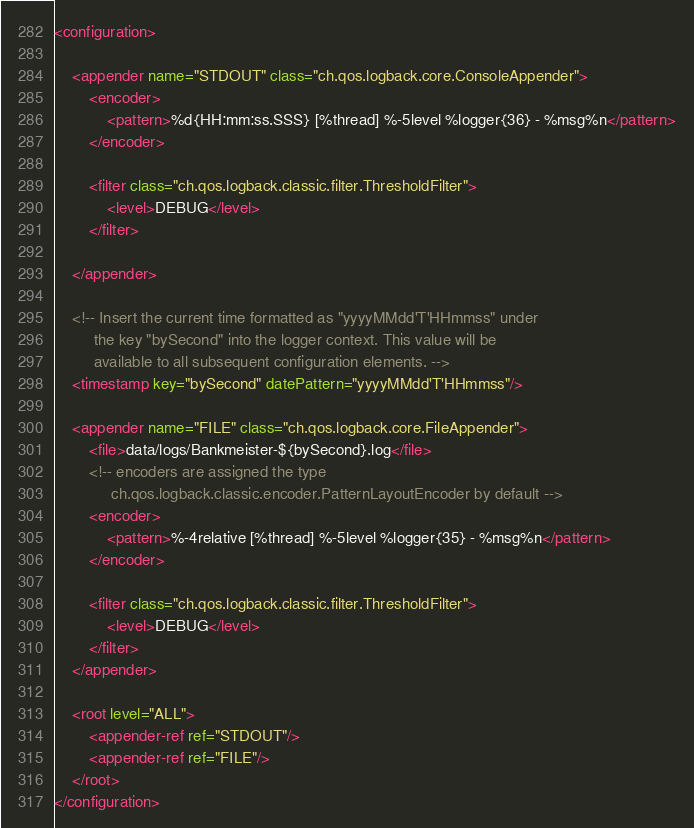Convert code to text. <code><loc_0><loc_0><loc_500><loc_500><_XML_><configuration>

    <appender name="STDOUT" class="ch.qos.logback.core.ConsoleAppender">
        <encoder>
            <pattern>%d{HH:mm:ss.SSS} [%thread] %-5level %logger{36} - %msg%n</pattern>
        </encoder>

        <filter class="ch.qos.logback.classic.filter.ThresholdFilter">
            <level>DEBUG</level>
        </filter>

    </appender>

    <!-- Insert the current time formatted as "yyyyMMdd'T'HHmmss" under
         the key "bySecond" into the logger context. This value will be
         available to all subsequent configuration elements. -->
    <timestamp key="bySecond" datePattern="yyyyMMdd'T'HHmmss"/>

    <appender name="FILE" class="ch.qos.logback.core.FileAppender">
        <file>data/logs/Bankmeister-${bySecond}.log</file>
        <!-- encoders are assigned the type
             ch.qos.logback.classic.encoder.PatternLayoutEncoder by default -->
        <encoder>
            <pattern>%-4relative [%thread] %-5level %logger{35} - %msg%n</pattern>
        </encoder>

        <filter class="ch.qos.logback.classic.filter.ThresholdFilter">
            <level>DEBUG</level>
        </filter>
    </appender>

    <root level="ALL">
        <appender-ref ref="STDOUT"/>
        <appender-ref ref="FILE"/>
    </root>
</configuration></code> 